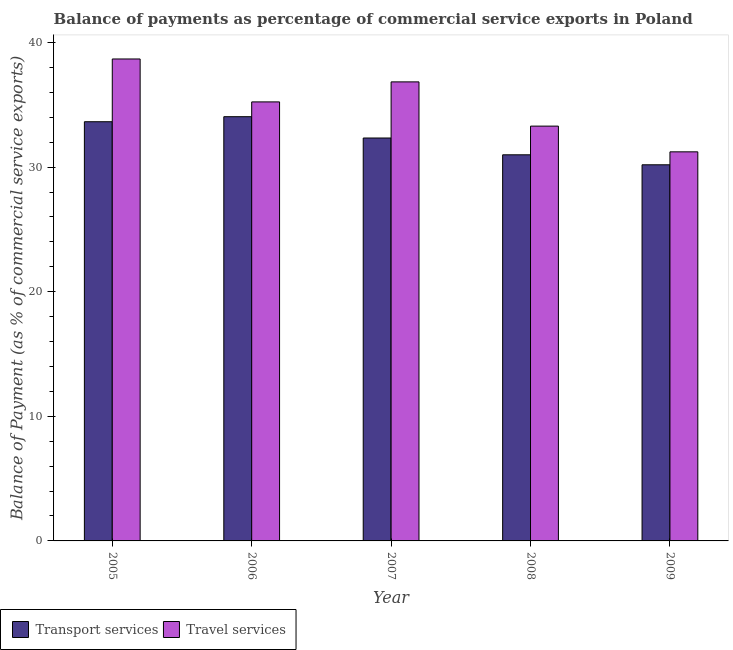How many different coloured bars are there?
Provide a short and direct response. 2. Are the number of bars per tick equal to the number of legend labels?
Your response must be concise. Yes. How many bars are there on the 1st tick from the left?
Your answer should be compact. 2. How many bars are there on the 1st tick from the right?
Offer a very short reply. 2. What is the label of the 1st group of bars from the left?
Provide a succinct answer. 2005. What is the balance of payments of travel services in 2007?
Your response must be concise. 36.84. Across all years, what is the maximum balance of payments of transport services?
Offer a very short reply. 34.04. Across all years, what is the minimum balance of payments of transport services?
Ensure brevity in your answer.  30.18. In which year was the balance of payments of transport services maximum?
Ensure brevity in your answer.  2006. What is the total balance of payments of travel services in the graph?
Offer a very short reply. 175.26. What is the difference between the balance of payments of transport services in 2006 and that in 2007?
Keep it short and to the point. 1.71. What is the difference between the balance of payments of travel services in 2006 and the balance of payments of transport services in 2009?
Your answer should be very brief. 4.01. What is the average balance of payments of travel services per year?
Offer a very short reply. 35.05. In the year 2009, what is the difference between the balance of payments of transport services and balance of payments of travel services?
Provide a short and direct response. 0. What is the ratio of the balance of payments of travel services in 2005 to that in 2007?
Your answer should be compact. 1.05. Is the balance of payments of travel services in 2005 less than that in 2006?
Make the answer very short. No. What is the difference between the highest and the second highest balance of payments of travel services?
Make the answer very short. 1.84. What is the difference between the highest and the lowest balance of payments of travel services?
Keep it short and to the point. 7.45. What does the 2nd bar from the left in 2006 represents?
Offer a very short reply. Travel services. What does the 2nd bar from the right in 2008 represents?
Provide a short and direct response. Transport services. Are all the bars in the graph horizontal?
Keep it short and to the point. No. What is the difference between two consecutive major ticks on the Y-axis?
Offer a very short reply. 10. Are the values on the major ticks of Y-axis written in scientific E-notation?
Your answer should be compact. No. Does the graph contain any zero values?
Make the answer very short. No. Does the graph contain grids?
Keep it short and to the point. No. Where does the legend appear in the graph?
Keep it short and to the point. Bottom left. How are the legend labels stacked?
Offer a terse response. Horizontal. What is the title of the graph?
Provide a succinct answer. Balance of payments as percentage of commercial service exports in Poland. Does "Chemicals" appear as one of the legend labels in the graph?
Provide a short and direct response. No. What is the label or title of the Y-axis?
Your response must be concise. Balance of Payment (as % of commercial service exports). What is the Balance of Payment (as % of commercial service exports) of Transport services in 2005?
Offer a terse response. 33.64. What is the Balance of Payment (as % of commercial service exports) in Travel services in 2005?
Offer a terse response. 38.68. What is the Balance of Payment (as % of commercial service exports) in Transport services in 2006?
Ensure brevity in your answer.  34.04. What is the Balance of Payment (as % of commercial service exports) in Travel services in 2006?
Provide a succinct answer. 35.23. What is the Balance of Payment (as % of commercial service exports) in Transport services in 2007?
Make the answer very short. 32.33. What is the Balance of Payment (as % of commercial service exports) of Travel services in 2007?
Give a very brief answer. 36.84. What is the Balance of Payment (as % of commercial service exports) of Transport services in 2008?
Offer a very short reply. 30.99. What is the Balance of Payment (as % of commercial service exports) in Travel services in 2008?
Your response must be concise. 33.29. What is the Balance of Payment (as % of commercial service exports) in Transport services in 2009?
Your answer should be very brief. 30.18. What is the Balance of Payment (as % of commercial service exports) of Travel services in 2009?
Offer a very short reply. 31.22. Across all years, what is the maximum Balance of Payment (as % of commercial service exports) of Transport services?
Provide a succinct answer. 34.04. Across all years, what is the maximum Balance of Payment (as % of commercial service exports) of Travel services?
Your answer should be compact. 38.68. Across all years, what is the minimum Balance of Payment (as % of commercial service exports) in Transport services?
Provide a succinct answer. 30.18. Across all years, what is the minimum Balance of Payment (as % of commercial service exports) in Travel services?
Keep it short and to the point. 31.22. What is the total Balance of Payment (as % of commercial service exports) of Transport services in the graph?
Ensure brevity in your answer.  161.19. What is the total Balance of Payment (as % of commercial service exports) in Travel services in the graph?
Keep it short and to the point. 175.26. What is the difference between the Balance of Payment (as % of commercial service exports) of Transport services in 2005 and that in 2006?
Make the answer very short. -0.4. What is the difference between the Balance of Payment (as % of commercial service exports) in Travel services in 2005 and that in 2006?
Keep it short and to the point. 3.44. What is the difference between the Balance of Payment (as % of commercial service exports) of Transport services in 2005 and that in 2007?
Ensure brevity in your answer.  1.31. What is the difference between the Balance of Payment (as % of commercial service exports) of Travel services in 2005 and that in 2007?
Your response must be concise. 1.84. What is the difference between the Balance of Payment (as % of commercial service exports) in Transport services in 2005 and that in 2008?
Offer a very short reply. 2.65. What is the difference between the Balance of Payment (as % of commercial service exports) of Travel services in 2005 and that in 2008?
Keep it short and to the point. 5.39. What is the difference between the Balance of Payment (as % of commercial service exports) of Transport services in 2005 and that in 2009?
Give a very brief answer. 3.46. What is the difference between the Balance of Payment (as % of commercial service exports) in Travel services in 2005 and that in 2009?
Give a very brief answer. 7.45. What is the difference between the Balance of Payment (as % of commercial service exports) in Transport services in 2006 and that in 2007?
Offer a terse response. 1.71. What is the difference between the Balance of Payment (as % of commercial service exports) of Travel services in 2006 and that in 2007?
Give a very brief answer. -1.61. What is the difference between the Balance of Payment (as % of commercial service exports) of Transport services in 2006 and that in 2008?
Keep it short and to the point. 3.06. What is the difference between the Balance of Payment (as % of commercial service exports) in Travel services in 2006 and that in 2008?
Your response must be concise. 1.94. What is the difference between the Balance of Payment (as % of commercial service exports) in Transport services in 2006 and that in 2009?
Your answer should be compact. 3.86. What is the difference between the Balance of Payment (as % of commercial service exports) of Travel services in 2006 and that in 2009?
Provide a short and direct response. 4.01. What is the difference between the Balance of Payment (as % of commercial service exports) of Transport services in 2007 and that in 2008?
Offer a very short reply. 1.35. What is the difference between the Balance of Payment (as % of commercial service exports) in Travel services in 2007 and that in 2008?
Offer a terse response. 3.55. What is the difference between the Balance of Payment (as % of commercial service exports) of Transport services in 2007 and that in 2009?
Ensure brevity in your answer.  2.15. What is the difference between the Balance of Payment (as % of commercial service exports) in Travel services in 2007 and that in 2009?
Your answer should be compact. 5.61. What is the difference between the Balance of Payment (as % of commercial service exports) of Transport services in 2008 and that in 2009?
Your answer should be compact. 0.8. What is the difference between the Balance of Payment (as % of commercial service exports) of Travel services in 2008 and that in 2009?
Make the answer very short. 2.06. What is the difference between the Balance of Payment (as % of commercial service exports) in Transport services in 2005 and the Balance of Payment (as % of commercial service exports) in Travel services in 2006?
Keep it short and to the point. -1.59. What is the difference between the Balance of Payment (as % of commercial service exports) in Transport services in 2005 and the Balance of Payment (as % of commercial service exports) in Travel services in 2007?
Offer a terse response. -3.2. What is the difference between the Balance of Payment (as % of commercial service exports) in Transport services in 2005 and the Balance of Payment (as % of commercial service exports) in Travel services in 2008?
Provide a short and direct response. 0.35. What is the difference between the Balance of Payment (as % of commercial service exports) in Transport services in 2005 and the Balance of Payment (as % of commercial service exports) in Travel services in 2009?
Offer a very short reply. 2.42. What is the difference between the Balance of Payment (as % of commercial service exports) in Transport services in 2006 and the Balance of Payment (as % of commercial service exports) in Travel services in 2007?
Your answer should be compact. -2.79. What is the difference between the Balance of Payment (as % of commercial service exports) in Transport services in 2006 and the Balance of Payment (as % of commercial service exports) in Travel services in 2008?
Offer a terse response. 0.76. What is the difference between the Balance of Payment (as % of commercial service exports) in Transport services in 2006 and the Balance of Payment (as % of commercial service exports) in Travel services in 2009?
Ensure brevity in your answer.  2.82. What is the difference between the Balance of Payment (as % of commercial service exports) in Transport services in 2007 and the Balance of Payment (as % of commercial service exports) in Travel services in 2008?
Offer a very short reply. -0.95. What is the difference between the Balance of Payment (as % of commercial service exports) of Transport services in 2007 and the Balance of Payment (as % of commercial service exports) of Travel services in 2009?
Make the answer very short. 1.11. What is the difference between the Balance of Payment (as % of commercial service exports) in Transport services in 2008 and the Balance of Payment (as % of commercial service exports) in Travel services in 2009?
Ensure brevity in your answer.  -0.24. What is the average Balance of Payment (as % of commercial service exports) in Transport services per year?
Offer a terse response. 32.24. What is the average Balance of Payment (as % of commercial service exports) of Travel services per year?
Ensure brevity in your answer.  35.05. In the year 2005, what is the difference between the Balance of Payment (as % of commercial service exports) of Transport services and Balance of Payment (as % of commercial service exports) of Travel services?
Your response must be concise. -5.04. In the year 2006, what is the difference between the Balance of Payment (as % of commercial service exports) of Transport services and Balance of Payment (as % of commercial service exports) of Travel services?
Make the answer very short. -1.19. In the year 2007, what is the difference between the Balance of Payment (as % of commercial service exports) in Transport services and Balance of Payment (as % of commercial service exports) in Travel services?
Keep it short and to the point. -4.5. In the year 2008, what is the difference between the Balance of Payment (as % of commercial service exports) in Transport services and Balance of Payment (as % of commercial service exports) in Travel services?
Offer a terse response. -2.3. In the year 2009, what is the difference between the Balance of Payment (as % of commercial service exports) of Transport services and Balance of Payment (as % of commercial service exports) of Travel services?
Ensure brevity in your answer.  -1.04. What is the ratio of the Balance of Payment (as % of commercial service exports) in Transport services in 2005 to that in 2006?
Give a very brief answer. 0.99. What is the ratio of the Balance of Payment (as % of commercial service exports) of Travel services in 2005 to that in 2006?
Provide a succinct answer. 1.1. What is the ratio of the Balance of Payment (as % of commercial service exports) in Transport services in 2005 to that in 2007?
Provide a short and direct response. 1.04. What is the ratio of the Balance of Payment (as % of commercial service exports) in Travel services in 2005 to that in 2007?
Keep it short and to the point. 1.05. What is the ratio of the Balance of Payment (as % of commercial service exports) of Transport services in 2005 to that in 2008?
Provide a succinct answer. 1.09. What is the ratio of the Balance of Payment (as % of commercial service exports) in Travel services in 2005 to that in 2008?
Keep it short and to the point. 1.16. What is the ratio of the Balance of Payment (as % of commercial service exports) of Transport services in 2005 to that in 2009?
Your answer should be compact. 1.11. What is the ratio of the Balance of Payment (as % of commercial service exports) of Travel services in 2005 to that in 2009?
Offer a very short reply. 1.24. What is the ratio of the Balance of Payment (as % of commercial service exports) in Transport services in 2006 to that in 2007?
Offer a terse response. 1.05. What is the ratio of the Balance of Payment (as % of commercial service exports) in Travel services in 2006 to that in 2007?
Provide a succinct answer. 0.96. What is the ratio of the Balance of Payment (as % of commercial service exports) in Transport services in 2006 to that in 2008?
Keep it short and to the point. 1.1. What is the ratio of the Balance of Payment (as % of commercial service exports) of Travel services in 2006 to that in 2008?
Your answer should be compact. 1.06. What is the ratio of the Balance of Payment (as % of commercial service exports) of Transport services in 2006 to that in 2009?
Your response must be concise. 1.13. What is the ratio of the Balance of Payment (as % of commercial service exports) of Travel services in 2006 to that in 2009?
Give a very brief answer. 1.13. What is the ratio of the Balance of Payment (as % of commercial service exports) of Transport services in 2007 to that in 2008?
Give a very brief answer. 1.04. What is the ratio of the Balance of Payment (as % of commercial service exports) of Travel services in 2007 to that in 2008?
Your answer should be very brief. 1.11. What is the ratio of the Balance of Payment (as % of commercial service exports) of Transport services in 2007 to that in 2009?
Provide a succinct answer. 1.07. What is the ratio of the Balance of Payment (as % of commercial service exports) in Travel services in 2007 to that in 2009?
Your answer should be very brief. 1.18. What is the ratio of the Balance of Payment (as % of commercial service exports) in Transport services in 2008 to that in 2009?
Your response must be concise. 1.03. What is the ratio of the Balance of Payment (as % of commercial service exports) in Travel services in 2008 to that in 2009?
Provide a short and direct response. 1.07. What is the difference between the highest and the second highest Balance of Payment (as % of commercial service exports) of Transport services?
Your answer should be very brief. 0.4. What is the difference between the highest and the second highest Balance of Payment (as % of commercial service exports) of Travel services?
Make the answer very short. 1.84. What is the difference between the highest and the lowest Balance of Payment (as % of commercial service exports) of Transport services?
Your response must be concise. 3.86. What is the difference between the highest and the lowest Balance of Payment (as % of commercial service exports) in Travel services?
Provide a succinct answer. 7.45. 